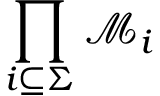Convert formula to latex. <formula><loc_0><loc_0><loc_500><loc_500>\prod _ { i \subseteq \Sigma } { \mathcal { M } } _ { i }</formula> 